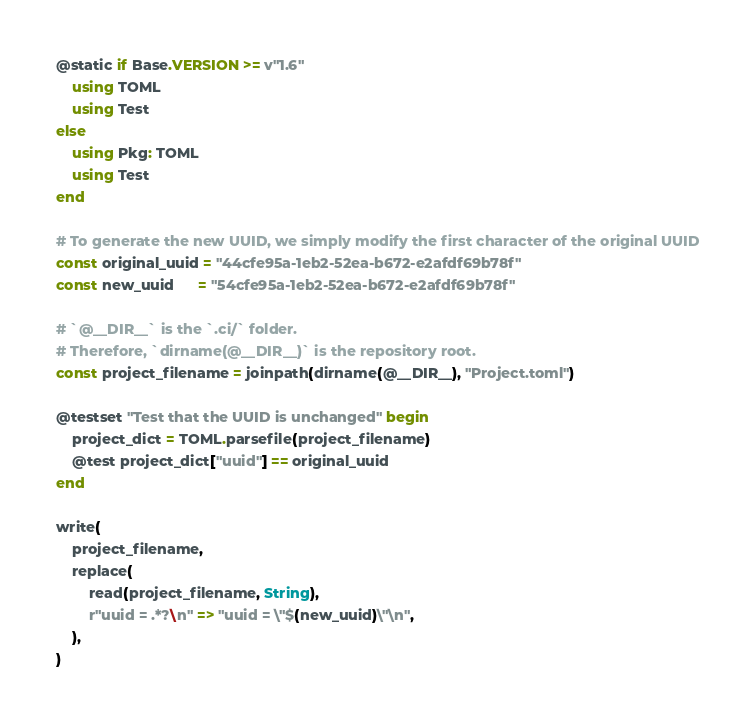Convert code to text. <code><loc_0><loc_0><loc_500><loc_500><_Julia_>@static if Base.VERSION >= v"1.6"
    using TOML
    using Test
else
    using Pkg: TOML
    using Test
end

# To generate the new UUID, we simply modify the first character of the original UUID
const original_uuid = "44cfe95a-1eb2-52ea-b672-e2afdf69b78f"
const new_uuid      = "54cfe95a-1eb2-52ea-b672-e2afdf69b78f"

# `@__DIR__` is the `.ci/` folder.
# Therefore, `dirname(@__DIR__)` is the repository root.
const project_filename = joinpath(dirname(@__DIR__), "Project.toml")

@testset "Test that the UUID is unchanged" begin
    project_dict = TOML.parsefile(project_filename)
    @test project_dict["uuid"] == original_uuid
end

write(
    project_filename,
    replace(
        read(project_filename, String),
        r"uuid = .*?\n" => "uuid = \"$(new_uuid)\"\n",
    ),
)
</code> 